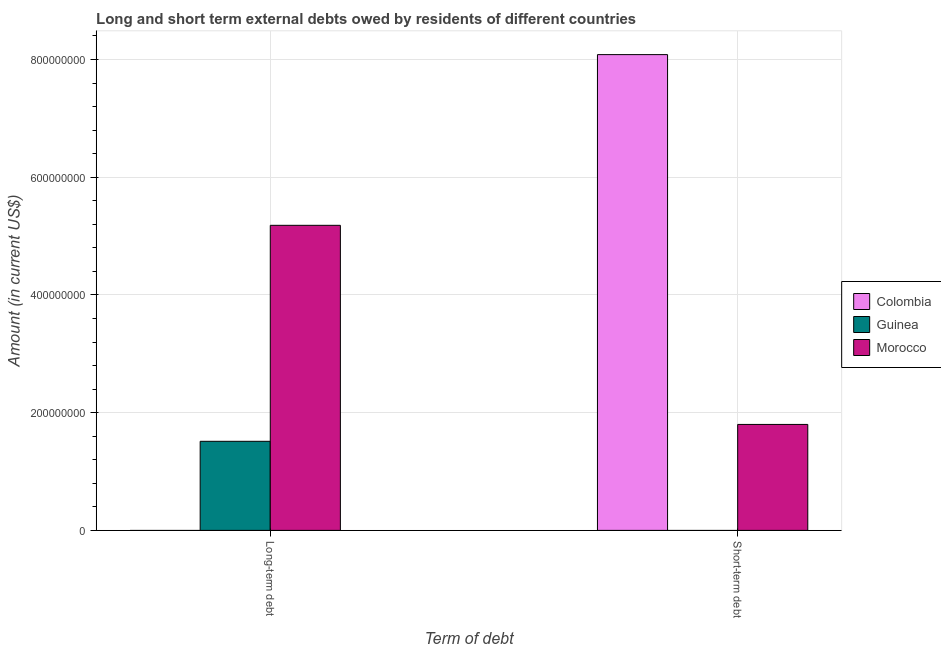How many groups of bars are there?
Provide a succinct answer. 2. Are the number of bars per tick equal to the number of legend labels?
Offer a terse response. No. How many bars are there on the 2nd tick from the right?
Ensure brevity in your answer.  2. What is the label of the 2nd group of bars from the left?
Give a very brief answer. Short-term debt. What is the long-term debts owed by residents in Colombia?
Provide a succinct answer. 0. Across all countries, what is the maximum long-term debts owed by residents?
Your answer should be compact. 5.18e+08. Across all countries, what is the minimum short-term debts owed by residents?
Provide a short and direct response. 0. In which country was the short-term debts owed by residents maximum?
Your answer should be very brief. Colombia. What is the total short-term debts owed by residents in the graph?
Your response must be concise. 9.88e+08. What is the difference between the short-term debts owed by residents in Colombia and that in Morocco?
Offer a terse response. 6.28e+08. What is the difference between the long-term debts owed by residents in Guinea and the short-term debts owed by residents in Colombia?
Offer a terse response. -6.57e+08. What is the average long-term debts owed by residents per country?
Offer a very short reply. 2.23e+08. What is the difference between the short-term debts owed by residents and long-term debts owed by residents in Morocco?
Make the answer very short. -3.38e+08. In how many countries, is the short-term debts owed by residents greater than 400000000 US$?
Your response must be concise. 1. What is the ratio of the long-term debts owed by residents in Guinea to that in Morocco?
Provide a succinct answer. 0.29. Is the short-term debts owed by residents in Colombia less than that in Morocco?
Make the answer very short. No. How many countries are there in the graph?
Keep it short and to the point. 3. What is the difference between two consecutive major ticks on the Y-axis?
Your response must be concise. 2.00e+08. Are the values on the major ticks of Y-axis written in scientific E-notation?
Your response must be concise. No. Does the graph contain grids?
Provide a succinct answer. Yes. How many legend labels are there?
Give a very brief answer. 3. What is the title of the graph?
Offer a terse response. Long and short term external debts owed by residents of different countries. What is the label or title of the X-axis?
Offer a very short reply. Term of debt. What is the Amount (in current US$) in Colombia in Long-term debt?
Ensure brevity in your answer.  0. What is the Amount (in current US$) in Guinea in Long-term debt?
Give a very brief answer. 1.51e+08. What is the Amount (in current US$) of Morocco in Long-term debt?
Give a very brief answer. 5.18e+08. What is the Amount (in current US$) in Colombia in Short-term debt?
Your response must be concise. 8.08e+08. What is the Amount (in current US$) of Morocco in Short-term debt?
Your answer should be compact. 1.80e+08. Across all Term of debt, what is the maximum Amount (in current US$) of Colombia?
Ensure brevity in your answer.  8.08e+08. Across all Term of debt, what is the maximum Amount (in current US$) of Guinea?
Ensure brevity in your answer.  1.51e+08. Across all Term of debt, what is the maximum Amount (in current US$) of Morocco?
Your answer should be compact. 5.18e+08. Across all Term of debt, what is the minimum Amount (in current US$) in Guinea?
Give a very brief answer. 0. Across all Term of debt, what is the minimum Amount (in current US$) of Morocco?
Your answer should be very brief. 1.80e+08. What is the total Amount (in current US$) in Colombia in the graph?
Provide a short and direct response. 8.08e+08. What is the total Amount (in current US$) in Guinea in the graph?
Provide a short and direct response. 1.51e+08. What is the total Amount (in current US$) in Morocco in the graph?
Your answer should be compact. 6.98e+08. What is the difference between the Amount (in current US$) in Morocco in Long-term debt and that in Short-term debt?
Make the answer very short. 3.38e+08. What is the difference between the Amount (in current US$) in Guinea in Long-term debt and the Amount (in current US$) in Morocco in Short-term debt?
Your answer should be compact. -2.87e+07. What is the average Amount (in current US$) of Colombia per Term of debt?
Your answer should be compact. 4.04e+08. What is the average Amount (in current US$) in Guinea per Term of debt?
Offer a very short reply. 7.57e+07. What is the average Amount (in current US$) in Morocco per Term of debt?
Keep it short and to the point. 3.49e+08. What is the difference between the Amount (in current US$) of Guinea and Amount (in current US$) of Morocco in Long-term debt?
Your response must be concise. -3.67e+08. What is the difference between the Amount (in current US$) in Colombia and Amount (in current US$) in Morocco in Short-term debt?
Your answer should be compact. 6.28e+08. What is the ratio of the Amount (in current US$) in Morocco in Long-term debt to that in Short-term debt?
Provide a short and direct response. 2.88. What is the difference between the highest and the second highest Amount (in current US$) of Morocco?
Provide a succinct answer. 3.38e+08. What is the difference between the highest and the lowest Amount (in current US$) in Colombia?
Give a very brief answer. 8.08e+08. What is the difference between the highest and the lowest Amount (in current US$) in Guinea?
Ensure brevity in your answer.  1.51e+08. What is the difference between the highest and the lowest Amount (in current US$) of Morocco?
Make the answer very short. 3.38e+08. 